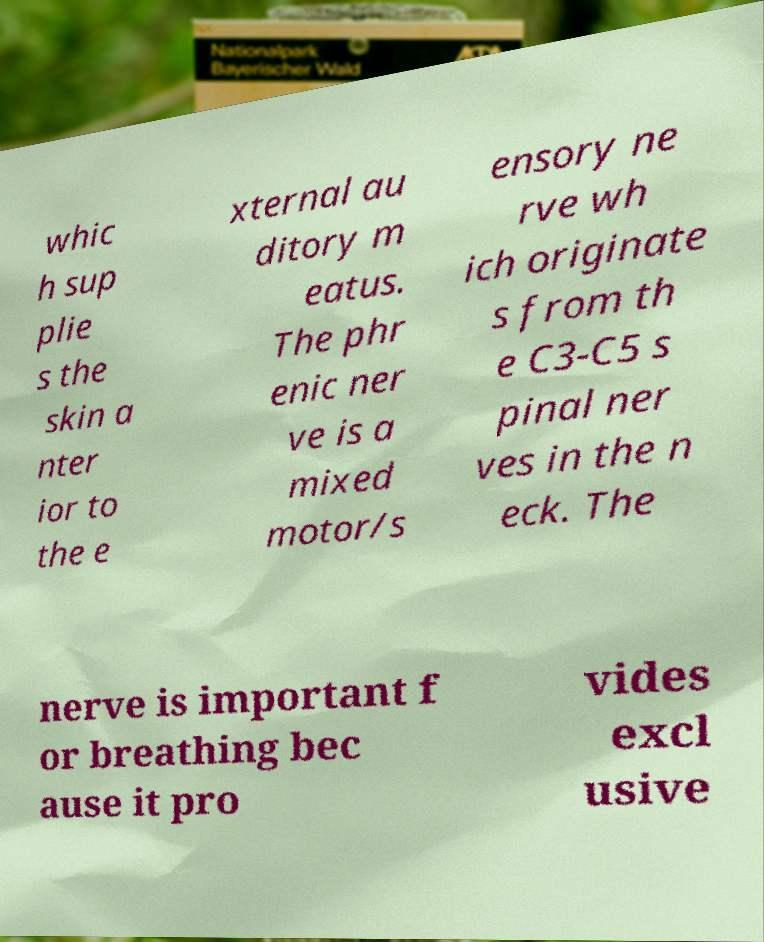Please identify and transcribe the text found in this image. whic h sup plie s the skin a nter ior to the e xternal au ditory m eatus. The phr enic ner ve is a mixed motor/s ensory ne rve wh ich originate s from th e C3-C5 s pinal ner ves in the n eck. The nerve is important f or breathing bec ause it pro vides excl usive 